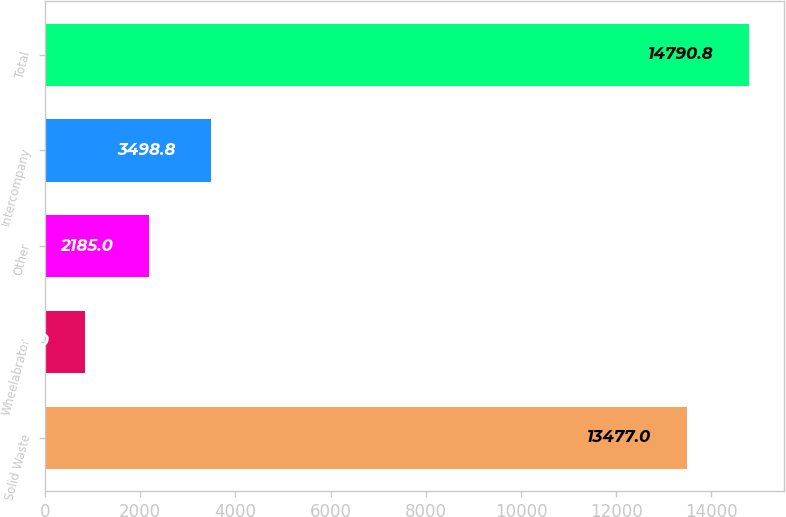Convert chart to OTSL. <chart><loc_0><loc_0><loc_500><loc_500><bar_chart><fcel>Solid Waste<fcel>Wheelabrator<fcel>Other<fcel>Intercompany<fcel>Total<nl><fcel>13477<fcel>845<fcel>2185<fcel>3498.8<fcel>14790.8<nl></chart> 